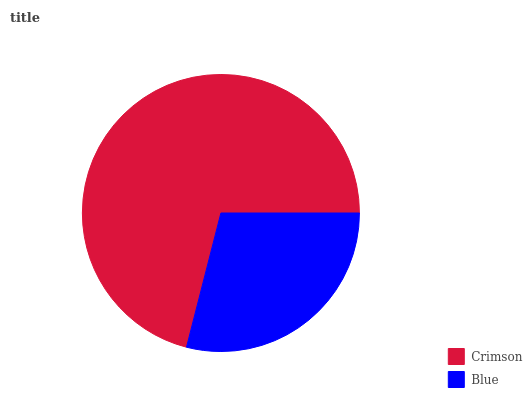Is Blue the minimum?
Answer yes or no. Yes. Is Crimson the maximum?
Answer yes or no. Yes. Is Blue the maximum?
Answer yes or no. No. Is Crimson greater than Blue?
Answer yes or no. Yes. Is Blue less than Crimson?
Answer yes or no. Yes. Is Blue greater than Crimson?
Answer yes or no. No. Is Crimson less than Blue?
Answer yes or no. No. Is Crimson the high median?
Answer yes or no. Yes. Is Blue the low median?
Answer yes or no. Yes. Is Blue the high median?
Answer yes or no. No. Is Crimson the low median?
Answer yes or no. No. 